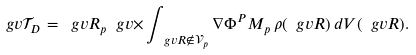Convert formula to latex. <formula><loc_0><loc_0><loc_500><loc_500>\ g v { \mathcal { T } _ { D } } = \ g v { R } _ { p } \ g v { \times } \int _ { \ g v { R } \notin \mathcal { V } _ { p } } \nabla \Phi ^ { P } M _ { p } \, \rho ( \ g v { R } ) \, d V ( \ g v { R } ) .</formula> 